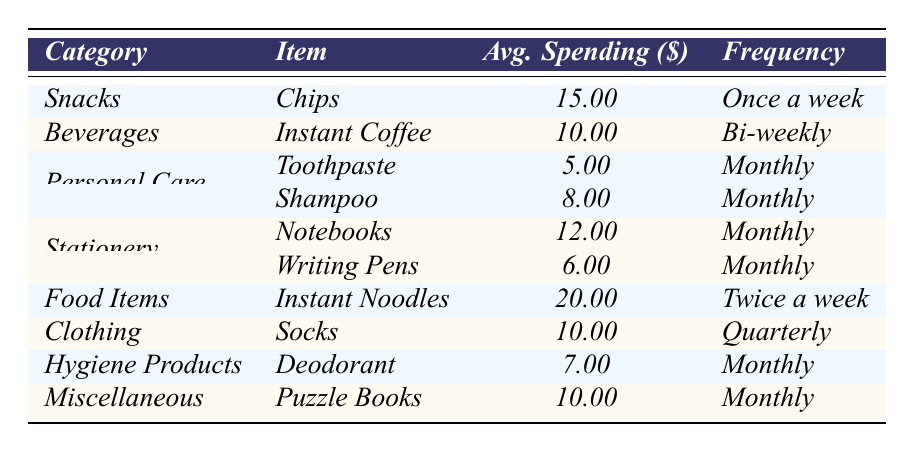What is the average spending on Instant Noodles? The average spending on Instant Noodles is listed in the table under "Food Items," where it shows an average of 20.00.
Answer: 20.00 How often is toothpaste purchased according to the table? The frequency for toothpaste is indicated as "Monthly" in the table under the "Personal Care" category.
Answer: Monthly What is the total average spending for snacks listed in the table? The only snack listed is Chips, with an average spending of 15.00, so the total for snacks is also 15.00.
Answer: 15.00 How much is spent on personal care items each month? The average spending for personal care items includes Toothpaste (5.00) and Shampoo (8.00). Adding these gives 5.00 + 8.00 = 13.00.
Answer: 13.00 Is the average spending on Deodorant higher than on Writing Pens? The average for Deodorant is 7.00, while Writing Pens is 6.00. Since 7.00 > 6.00, the answer is yes.
Answer: Yes What item from the Miscellaneous category has the same average spending as a Beverage category item? Puzzle Books under Miscellaneous has an average spending of 10.00, the same as Instant Coffee under Beverages, which is also 10.00.
Answer: Puzzle Books and Instant Coffee Calculate the average of spending on items under the Stationery category. The items are Notebooks (12.00) and Writing Pens (6.00). Their total is 12.00 + 6.00 = 18.00. To find the average, divide by the number of items (2): 18.00 / 2 = 9.00.
Answer: 9.00 How much is spent on hygiene products in total each month? The only hygiene item listed is Deodorant, which costs 7.00 on average. Thus, the total is 7.00.
Answer: 7.00 What is more frequent in purchasing: Snacks or Food Items? Snacks (Chips) are purchased once a week while Food Items (Instant Noodles) are purchased twice a week. Since once a week is less frequent than twice a week, Food Items are purchased more often.
Answer: Food Items Are there more items under Personal Care or under Stationery? There are two items under Personal Care (Toothpaste and Shampoo) and two items under Stationery (Notebooks and Writing Pens). Thus, both categories have the same number of items.
Answer: Equal number of items 